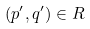Convert formula to latex. <formula><loc_0><loc_0><loc_500><loc_500>( p ^ { \prime } , q ^ { \prime } ) \in R</formula> 